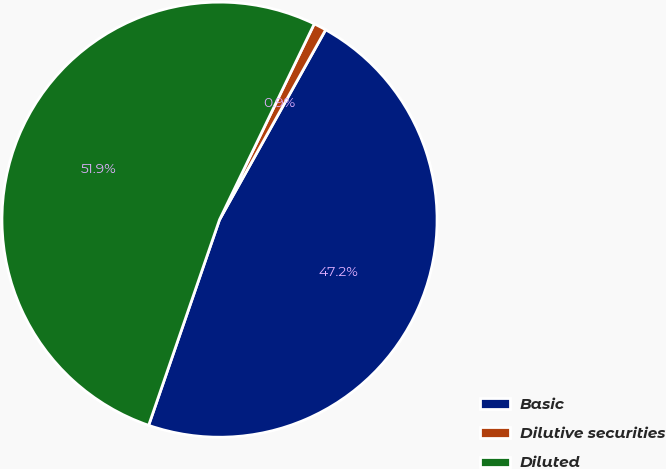Convert chart to OTSL. <chart><loc_0><loc_0><loc_500><loc_500><pie_chart><fcel>Basic<fcel>Dilutive securities<fcel>Diluted<nl><fcel>47.17%<fcel>0.94%<fcel>51.89%<nl></chart> 